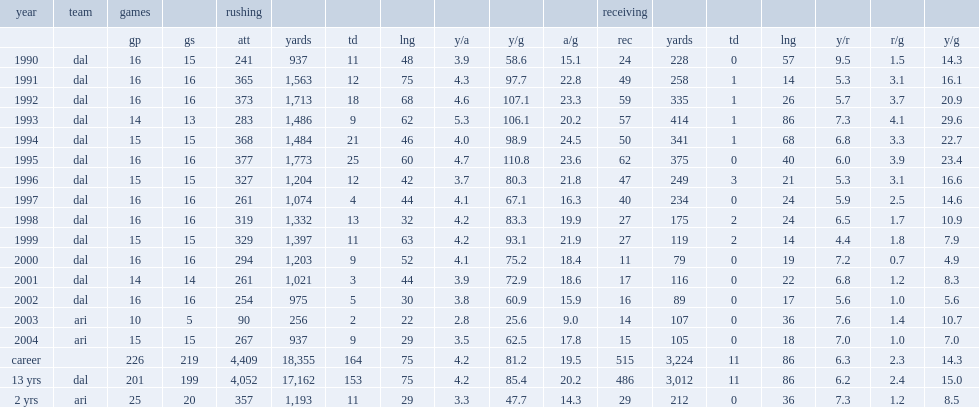How many rushing yards did emmitt smith get in 1992? 1713.0. 